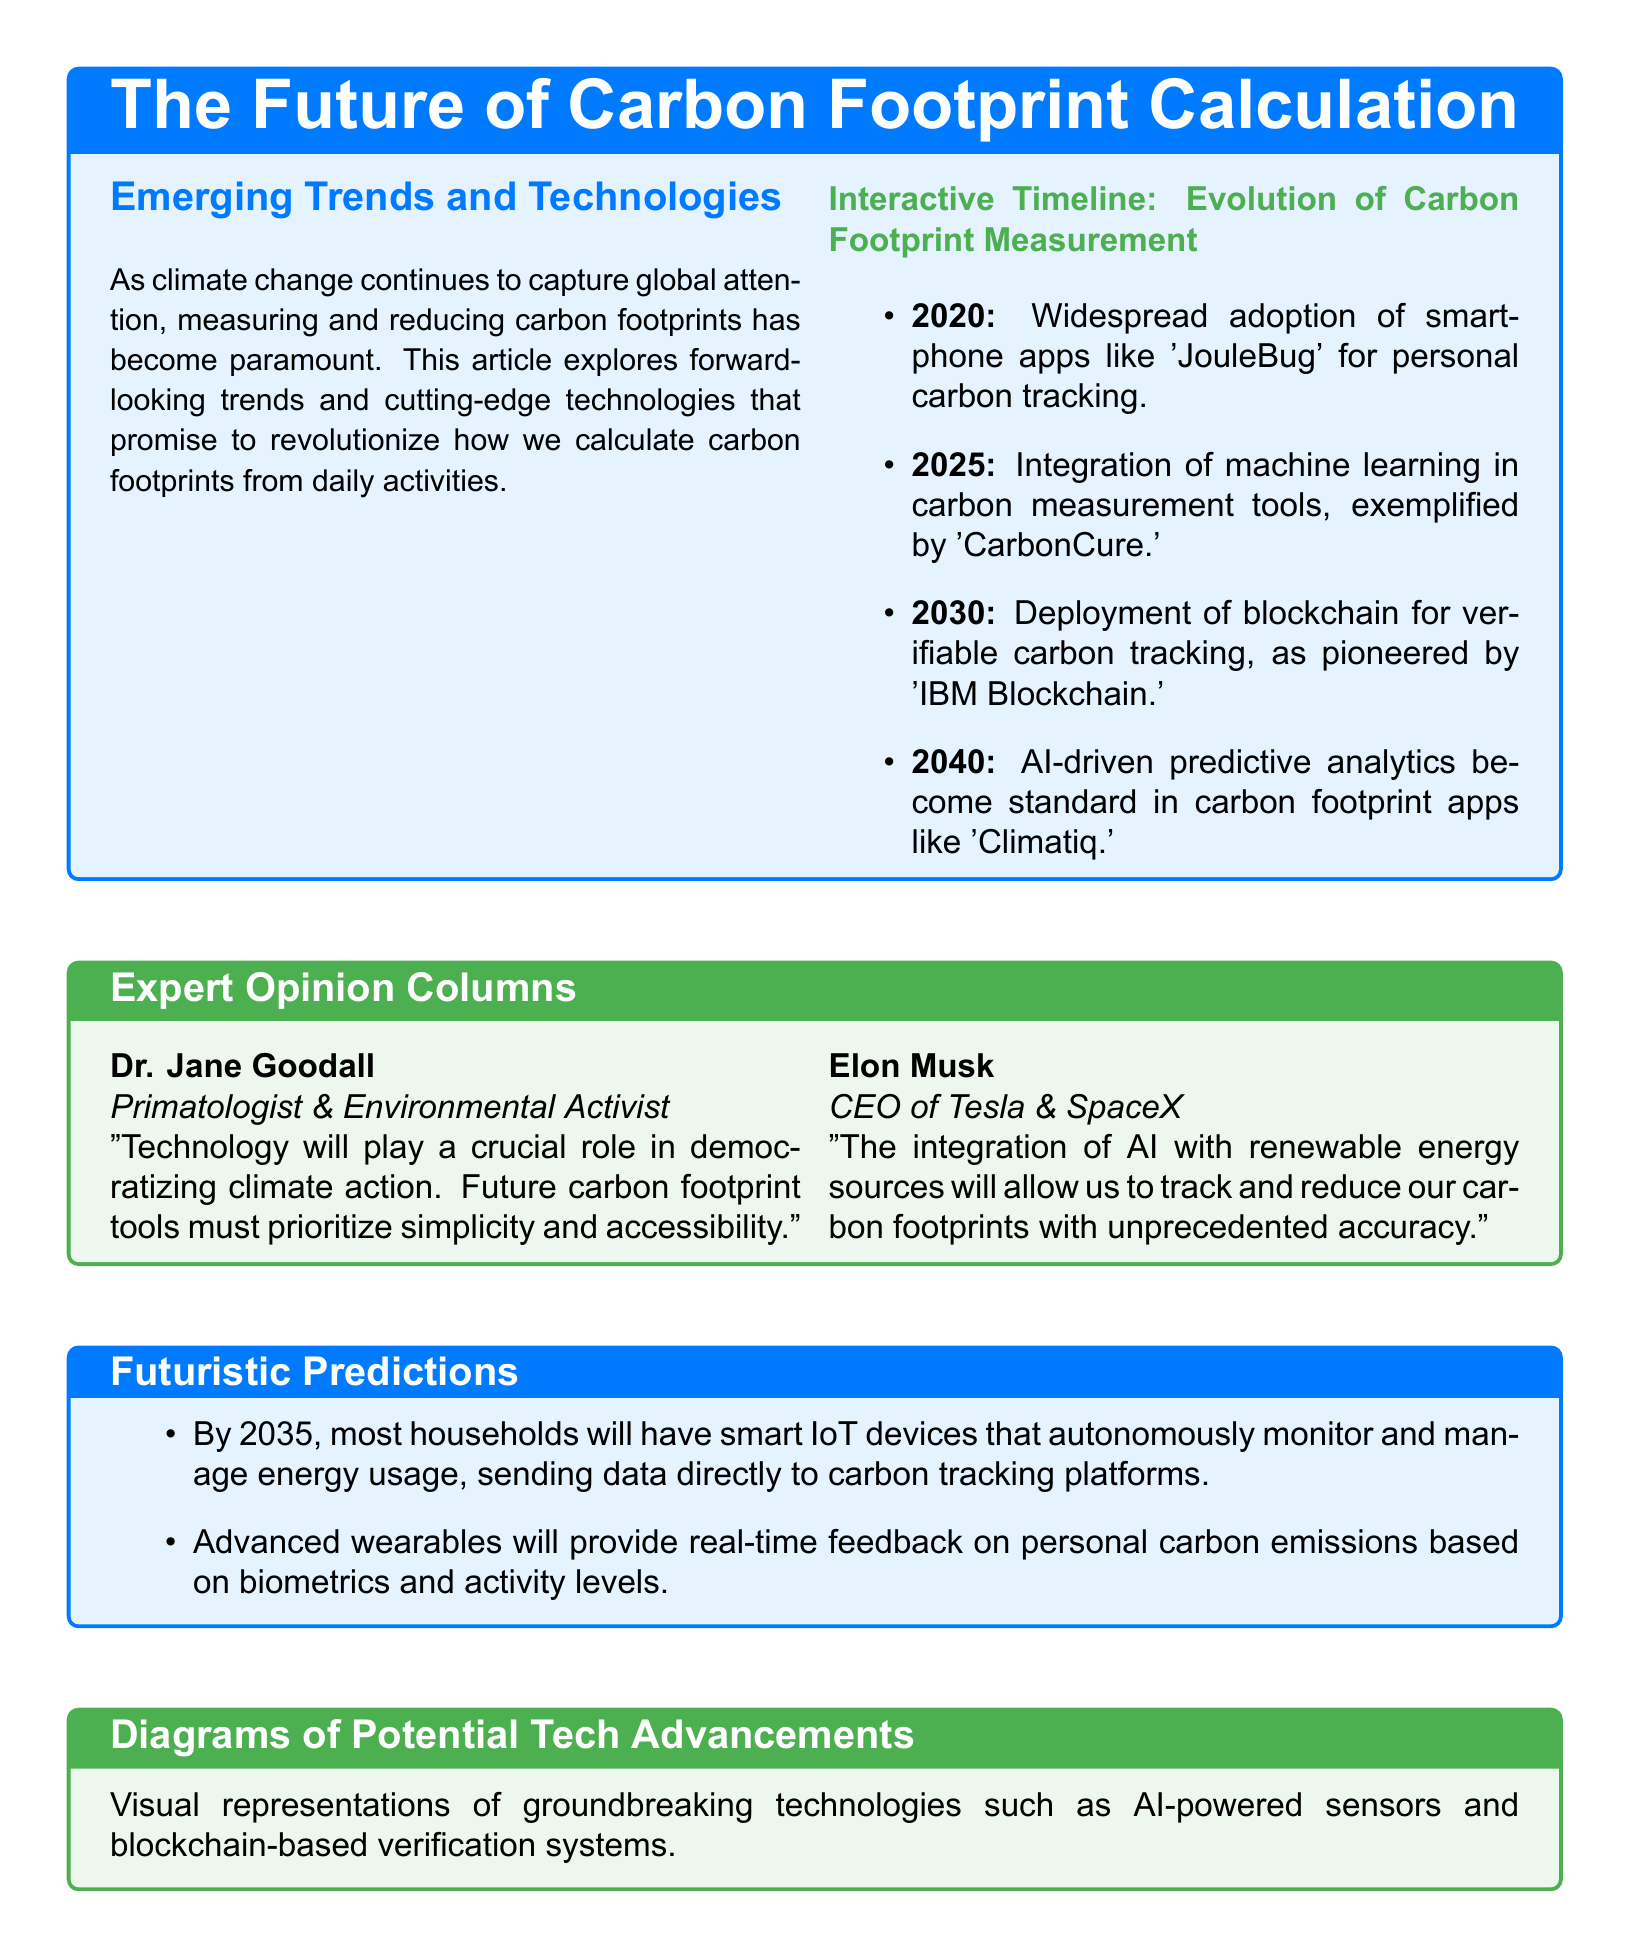What is the title of the article? The title is a key detail prominently displayed in the document, indicating its main theme.
Answer: The Future of Carbon Footprint Calculation Who is the CEO of Tesla? This information is provided as part of the expert opinion included in the document.
Answer: Elon Musk What year is predicted for the deployment of blockchain for carbon tracking? This specific year is mentioned in the Interactive Timeline as a significant milestone in technology advancement.
Answer: 2030 Which app is cited for the widespread adoption of carbon tracking in 2020? The document references this app to illustrate an early development in carbon footprint measurement technology.
Answer: JouleBug What does Dr. Jane Goodall emphasize as important for future carbon footprint tools? This highlights the key takeaway from Dr. Goodall's expert opinion, focusing on accessibility in technology.
Answer: Simplicity and accessibility What technology will households have by 2035 according to futuristic predictions? This prediction outlines a significant upcoming advancement in household technology related to energy management.
Answer: Smart IoT devices What is mentioned as a feature of advanced wearables? This detail describes the function of future advanced wearables in relation to carbon emissions.
Answer: Real-time feedback on emissions What color is used for the background of the Expert Opinion section? This details the formatting and visual style choices in the article.
Answer: Ecogreen 